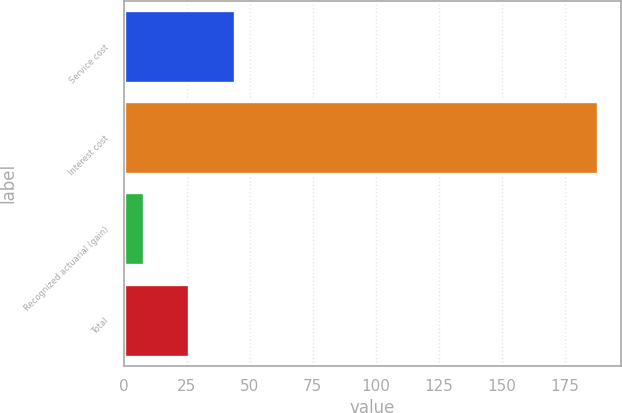<chart> <loc_0><loc_0><loc_500><loc_500><bar_chart><fcel>Service cost<fcel>Interest cost<fcel>Recognized actuarial (gain)<fcel>Total<nl><fcel>44<fcel>188<fcel>8<fcel>26<nl></chart> 